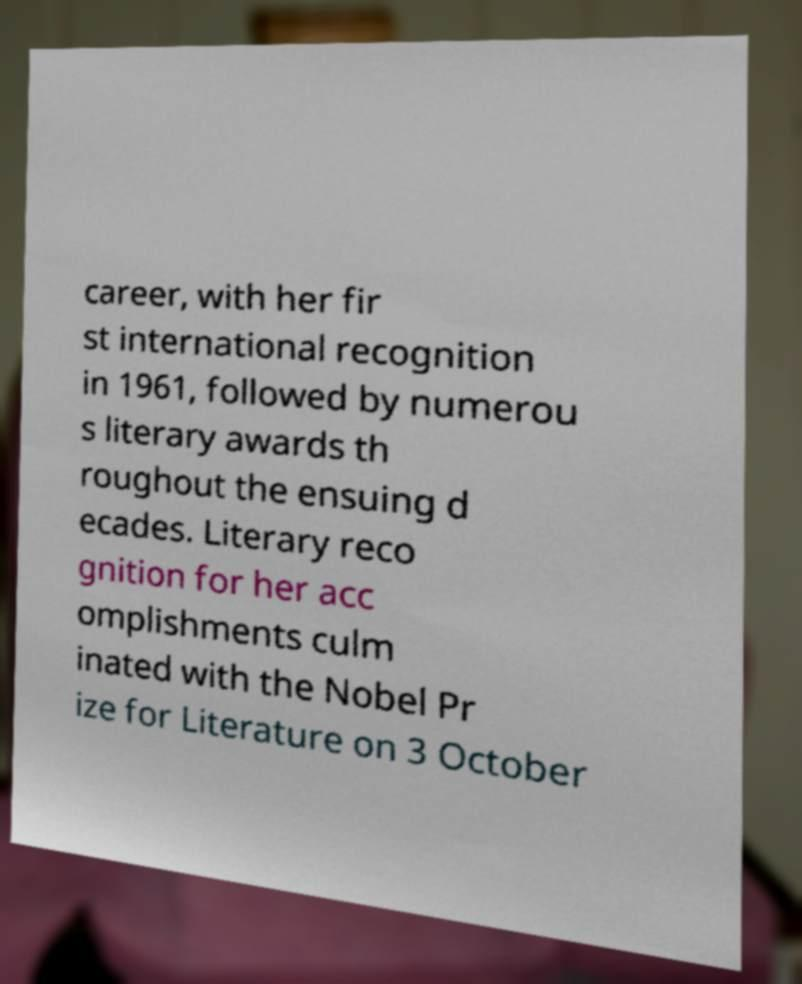Could you assist in decoding the text presented in this image and type it out clearly? career, with her fir st international recognition in 1961, followed by numerou s literary awards th roughout the ensuing d ecades. Literary reco gnition for her acc omplishments culm inated with the Nobel Pr ize for Literature on 3 October 